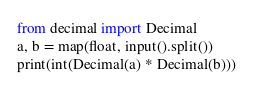Convert code to text. <code><loc_0><loc_0><loc_500><loc_500><_Python_>from decimal import Decimal
a, b = map(float, input().split())
print(int(Decimal(a) * Decimal(b)))</code> 